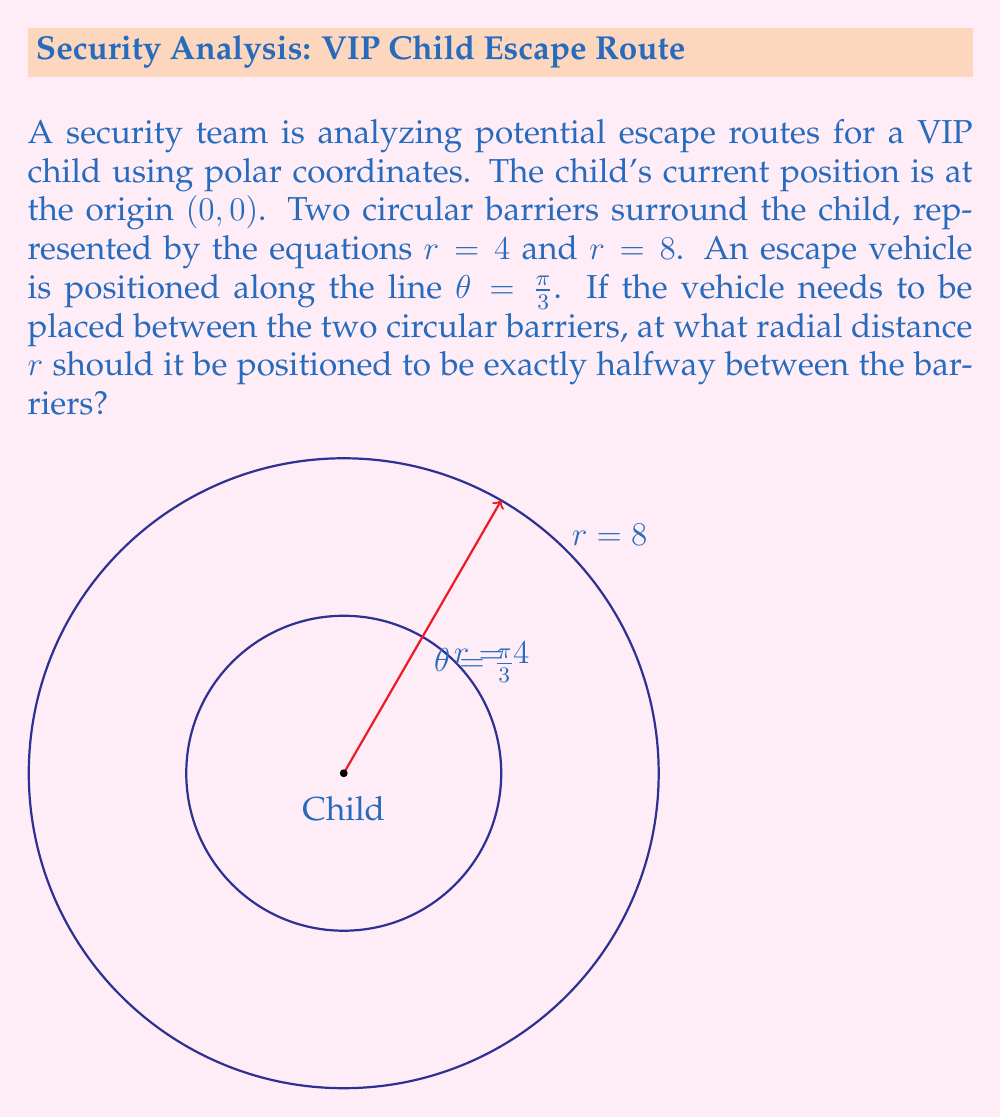Help me with this question. To solve this problem, let's follow these steps:

1) The inner barrier is given by $r = 4$ and the outer barrier by $r = 8$.

2) We need to find a point that is exactly halfway between these two barriers along the line $\theta = \frac{\pi}{3}$.

3) In polar coordinates, the distance between two points along the same angle is simply the difference of their r values.

4) The total distance between the barriers is $8 - 4 = 4$ units.

5) Half of this distance is $4 \div 2 = 2$ units.

6) Therefore, the escape vehicle should be positioned 2 units beyond the inner barrier.

7) We can calculate this as: $r = 4 + 2 = 6$

Thus, the radial distance $r$ at which the escape vehicle should be positioned is 6 units from the origin.
Answer: $r = 6$ 